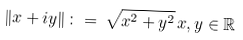<formula> <loc_0><loc_0><loc_500><loc_500>\| x + i y \| \, \colon = \, \sqrt { x ^ { 2 } + y ^ { 2 } } \, x , y \in { \mathbb { R } }</formula> 